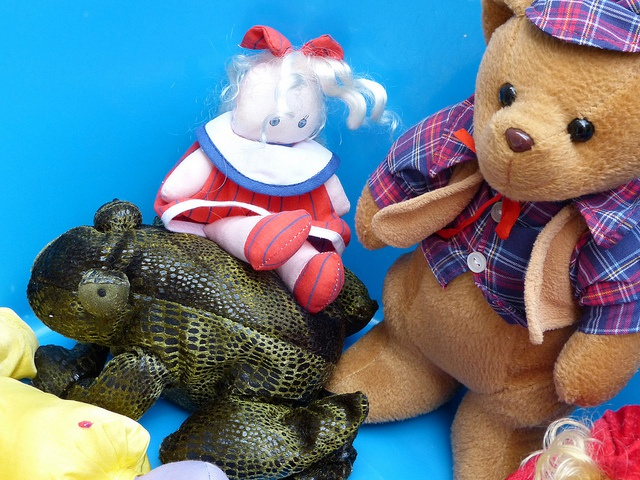Describe the objects in this image and their specific colors. I can see a teddy bear in lightblue, gray, maroon, and tan tones in this image. 